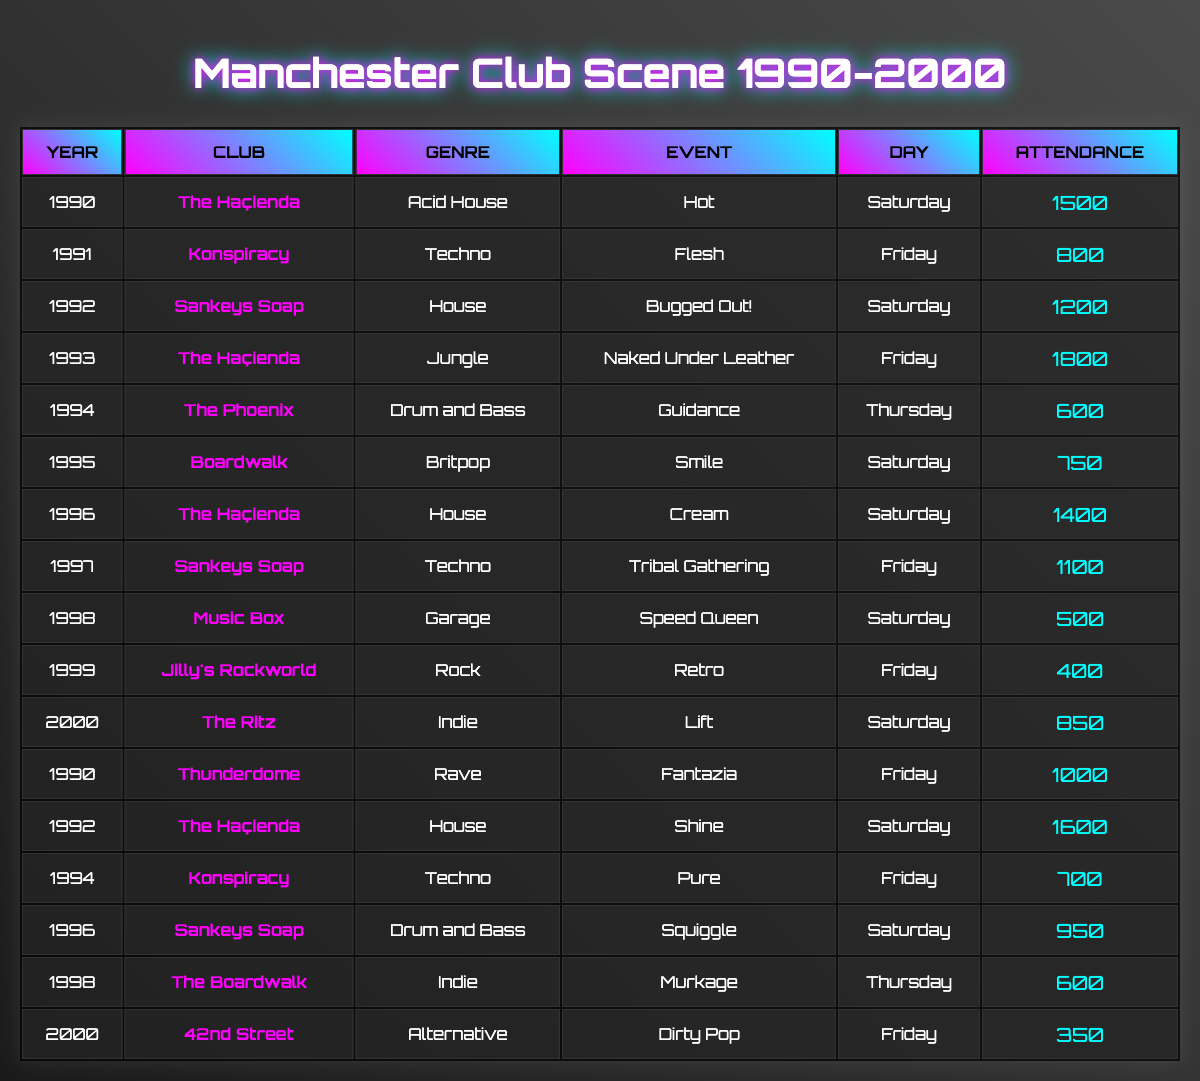What was the highest attendance recorded in a single event? The highest attendance is found by scanning through the attendance column in the table. The maximum attendance is 1800, which occurs at The Haçienda in 1993 during the event "Naked Under Leather."
Answer: 1800 Which club hosted the most events in this period? By counting the occurrences of each club listed in the table, The Haçienda shows up five times. This is the highest count among all clubs in the data.
Answer: The Haçienda What was the average attendance for events on Saturdays? To find the average attendance for Saturdays, the attendances for all events on that day must be summed. The total is (1500 + 1200 + 750 + 1400 + 500 + 850) = 4450. There are 6 Saturday events, so the average is 4450/6 = 741.67.
Answer: 741.67 Did any events in 1994 have an attendance of over 700? Checking the attendance figures for 1994, only The Phoenix with 600 and Konspiracy with 700 are listed. Since there is no event above 700, the answer is no.
Answer: No Which genre had the lowest overall attendance across its events? To determine the genre with the lowest attendance, the total attendance for each genre is calculated: Acid House (1500), Techno (800 + 700), House (1200 + 1600), Jungle (1800), Drum and Bass (600 + 950), Britpop (750), Garage (500), Rock (400), and Indie (600 + 850). The lowest total is for Rock with an attendance of 400.
Answer: Rock In what year did the event with the lowest attendance take place? The lowest attendance is 350, which occurs at 42nd Street in the year 2000 for the event "Dirty Pop." Hence, the year with the lowest attendance is 2000.
Answer: 2000 What were the total attendances for events at Sankeys Soap? The attendance at Sankeys Soap is 1200 (1992), 1100 (1997), and 950 (1996). Summing these gives a total attendance of 1200 + 1100 + 950 = 3250.
Answer: 3250 Were there more events held on Fridays than on Saturdays? Counting the events: there are 6 events on Fridays (1991, 1993, 1994, 1997, 1999, and 2000) and 6 on Saturdays (1990, 1992, 1995, 1996, 1998, and 2000). Since the counts are equal, the answer is no.
Answer: No What was the largest difference in attendance between events in a single year? Examining the years: in 1993, there was a difference of 1800 (The Haçienda) - 600 (The Phoenix) = 1200. In 1994, the difference is 700 - 600 = 100. The maximum difference, therefore, is in 1993.
Answer: 1200 